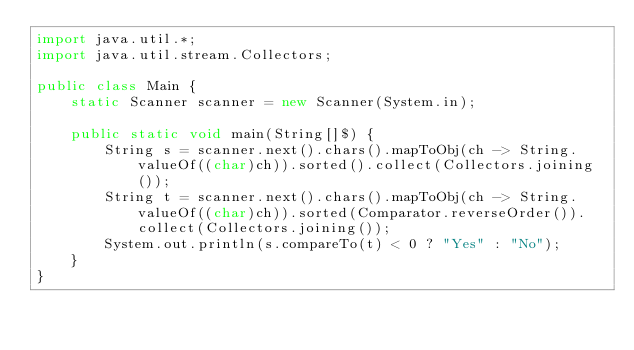Convert code to text. <code><loc_0><loc_0><loc_500><loc_500><_Java_>import java.util.*;
import java.util.stream.Collectors;

public class Main {
    static Scanner scanner = new Scanner(System.in);

    public static void main(String[]$) {
        String s = scanner.next().chars().mapToObj(ch -> String.valueOf((char)ch)).sorted().collect(Collectors.joining());
        String t = scanner.next().chars().mapToObj(ch -> String.valueOf((char)ch)).sorted(Comparator.reverseOrder()).collect(Collectors.joining());
        System.out.println(s.compareTo(t) < 0 ? "Yes" : "No");
    }
}</code> 